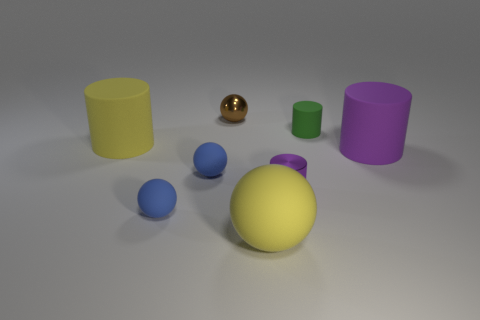Add 1 blue matte objects. How many objects exist? 9 Add 1 yellow spheres. How many yellow spheres are left? 2 Add 5 yellow matte things. How many yellow matte things exist? 7 Subtract 0 yellow blocks. How many objects are left? 8 Subtract all small rubber cylinders. Subtract all large rubber objects. How many objects are left? 4 